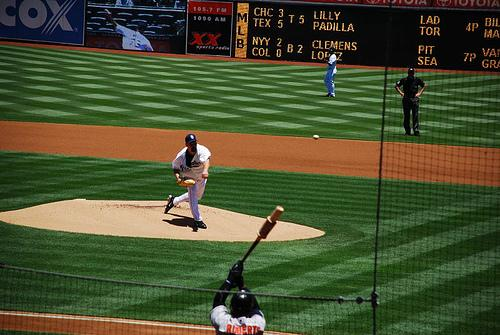Who conducts baseball league? Please explain your reasoning. mlb. The major league baseball organization is responsible for professional baseball. 